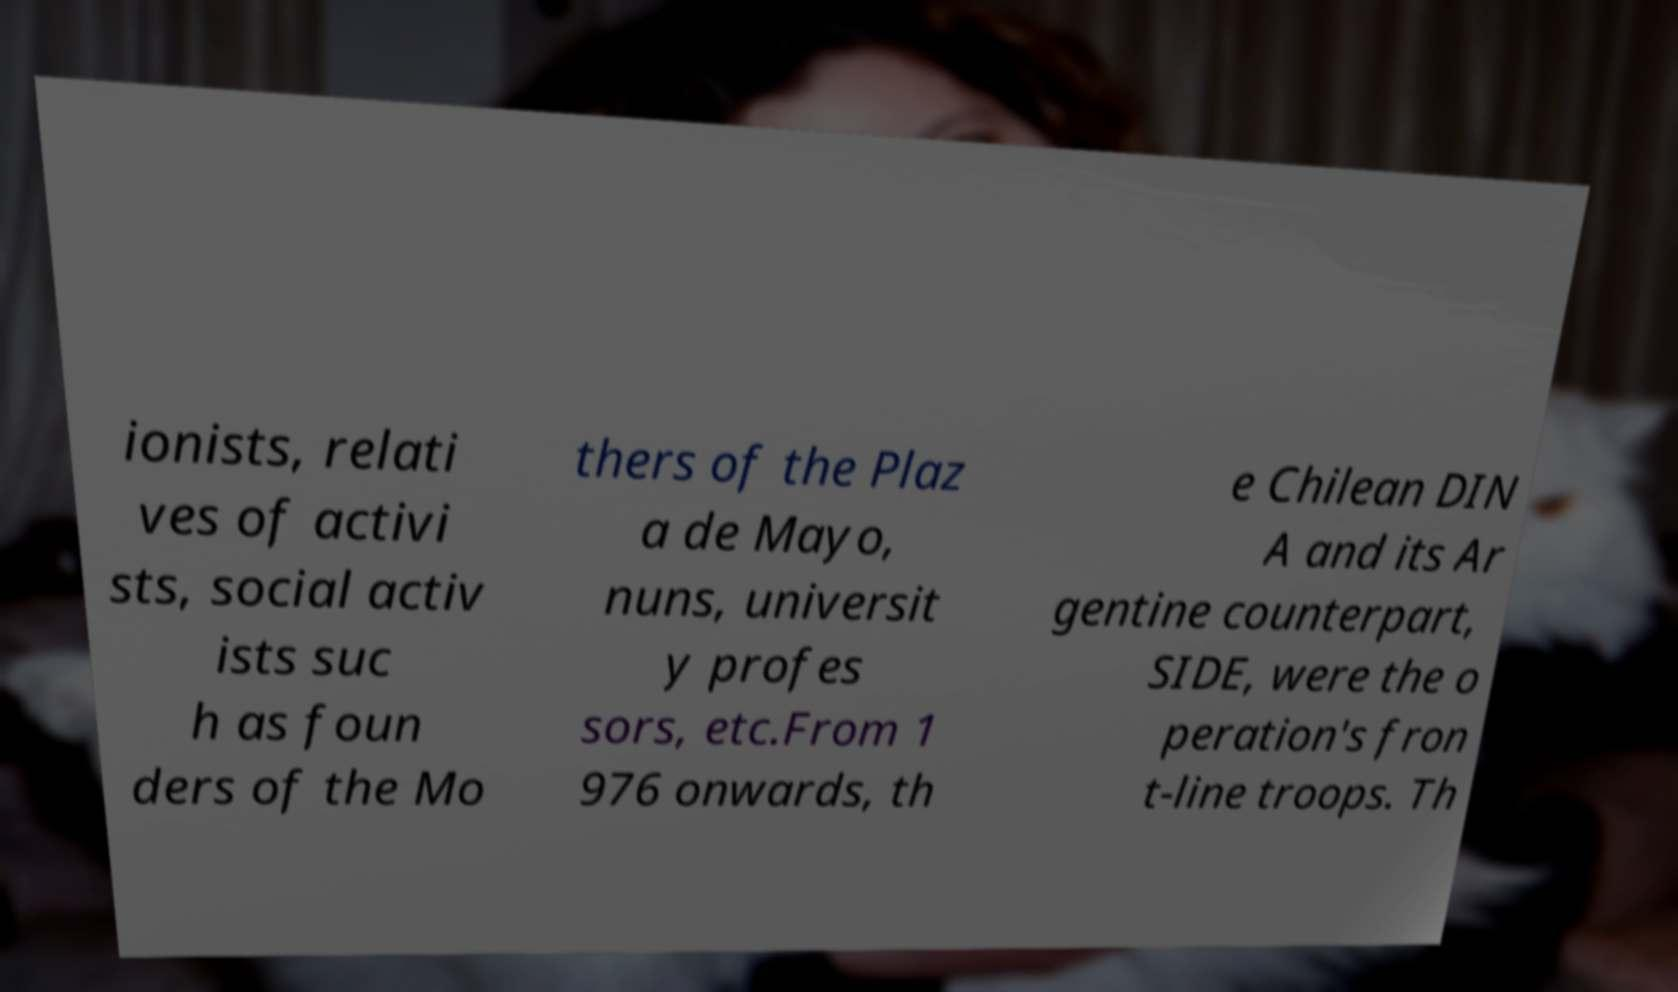Please read and relay the text visible in this image. What does it say? ionists, relati ves of activi sts, social activ ists suc h as foun ders of the Mo thers of the Plaz a de Mayo, nuns, universit y profes sors, etc.From 1 976 onwards, th e Chilean DIN A and its Ar gentine counterpart, SIDE, were the o peration's fron t-line troops. Th 